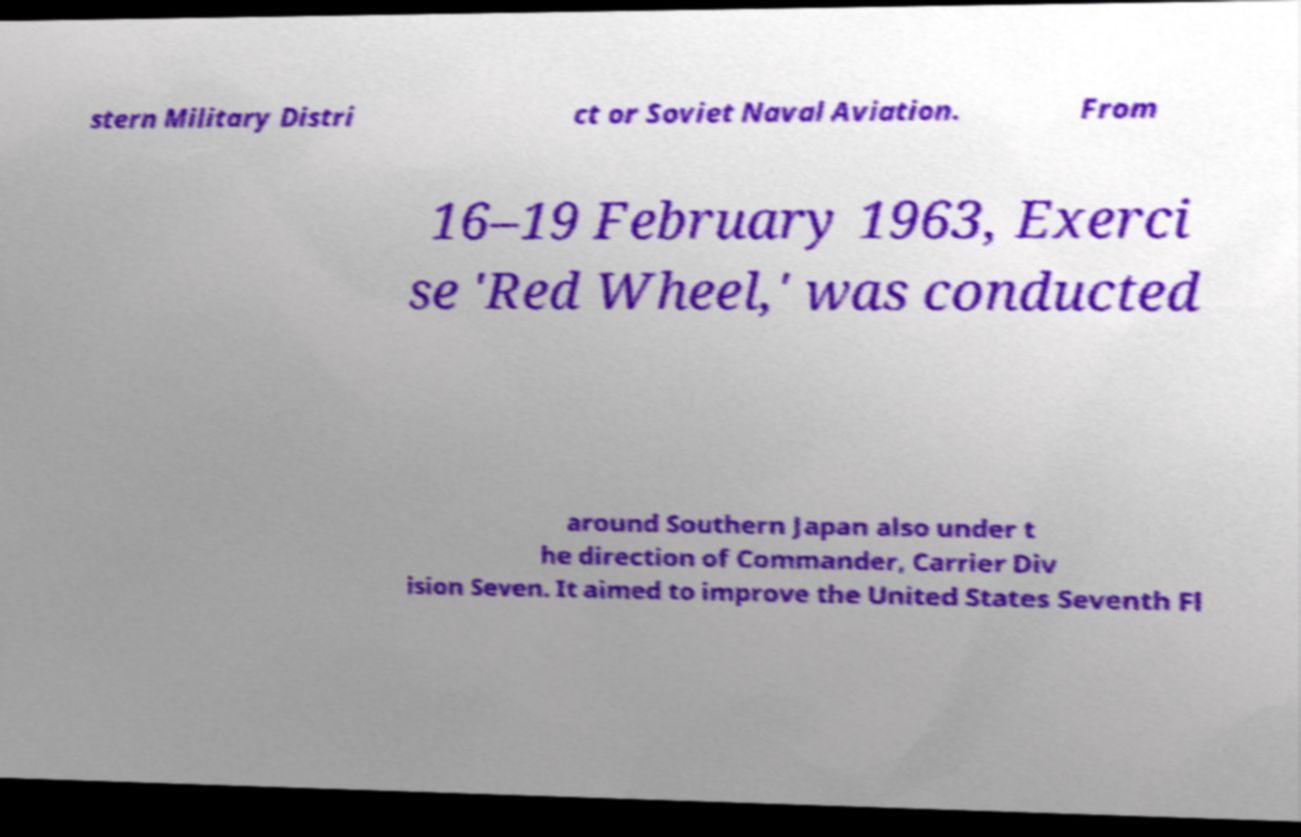Can you accurately transcribe the text from the provided image for me? stern Military Distri ct or Soviet Naval Aviation. From 16–19 February 1963, Exerci se 'Red Wheel,' was conducted around Southern Japan also under t he direction of Commander, Carrier Div ision Seven. It aimed to improve the United States Seventh Fl 